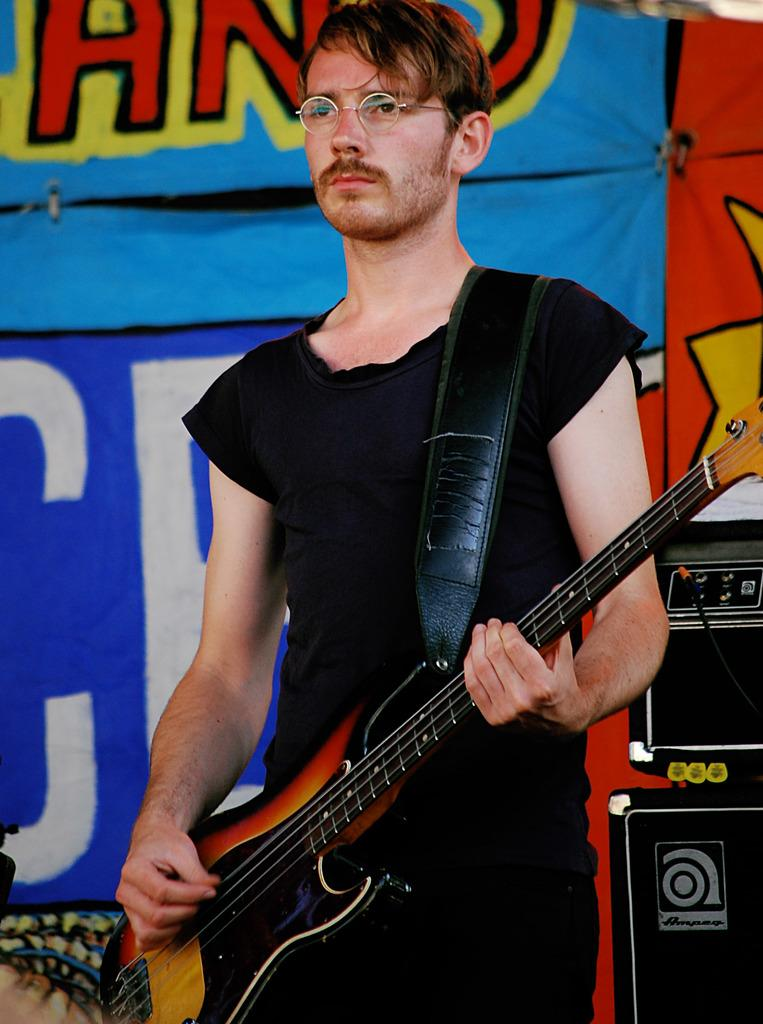Who is the main subject in the image? There is a man in the image. What is the man wearing? The man is wearing a black dress. What is the man doing in the image? The man is playing a guitar. What accessory is the man wearing? The man is wearing glasses. What else can be seen in the image besides the man? There are musical instruments beside the man and a banner in the background of the image. Reasoning: Let's think step by following the steps to produce the conversation. We start by identifying the main subject in the image, which is the man. Then, we describe the man's clothing and accessories, as well as his actions. Next, we mention the presence of other objects in the image, such as musical instruments and a banner. Each question is designed to elicit a specific detail about the image that is known from the provided facts. Absurd Question/Answer: What type of event is happening in the image? There is no specific event mentioned or depicted in the image. What type of expansion is happening in the image? There is no expansion happening in the image; it is a static scene featuring a man playing a guitar. 